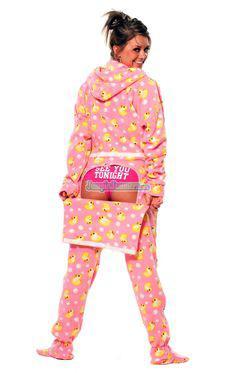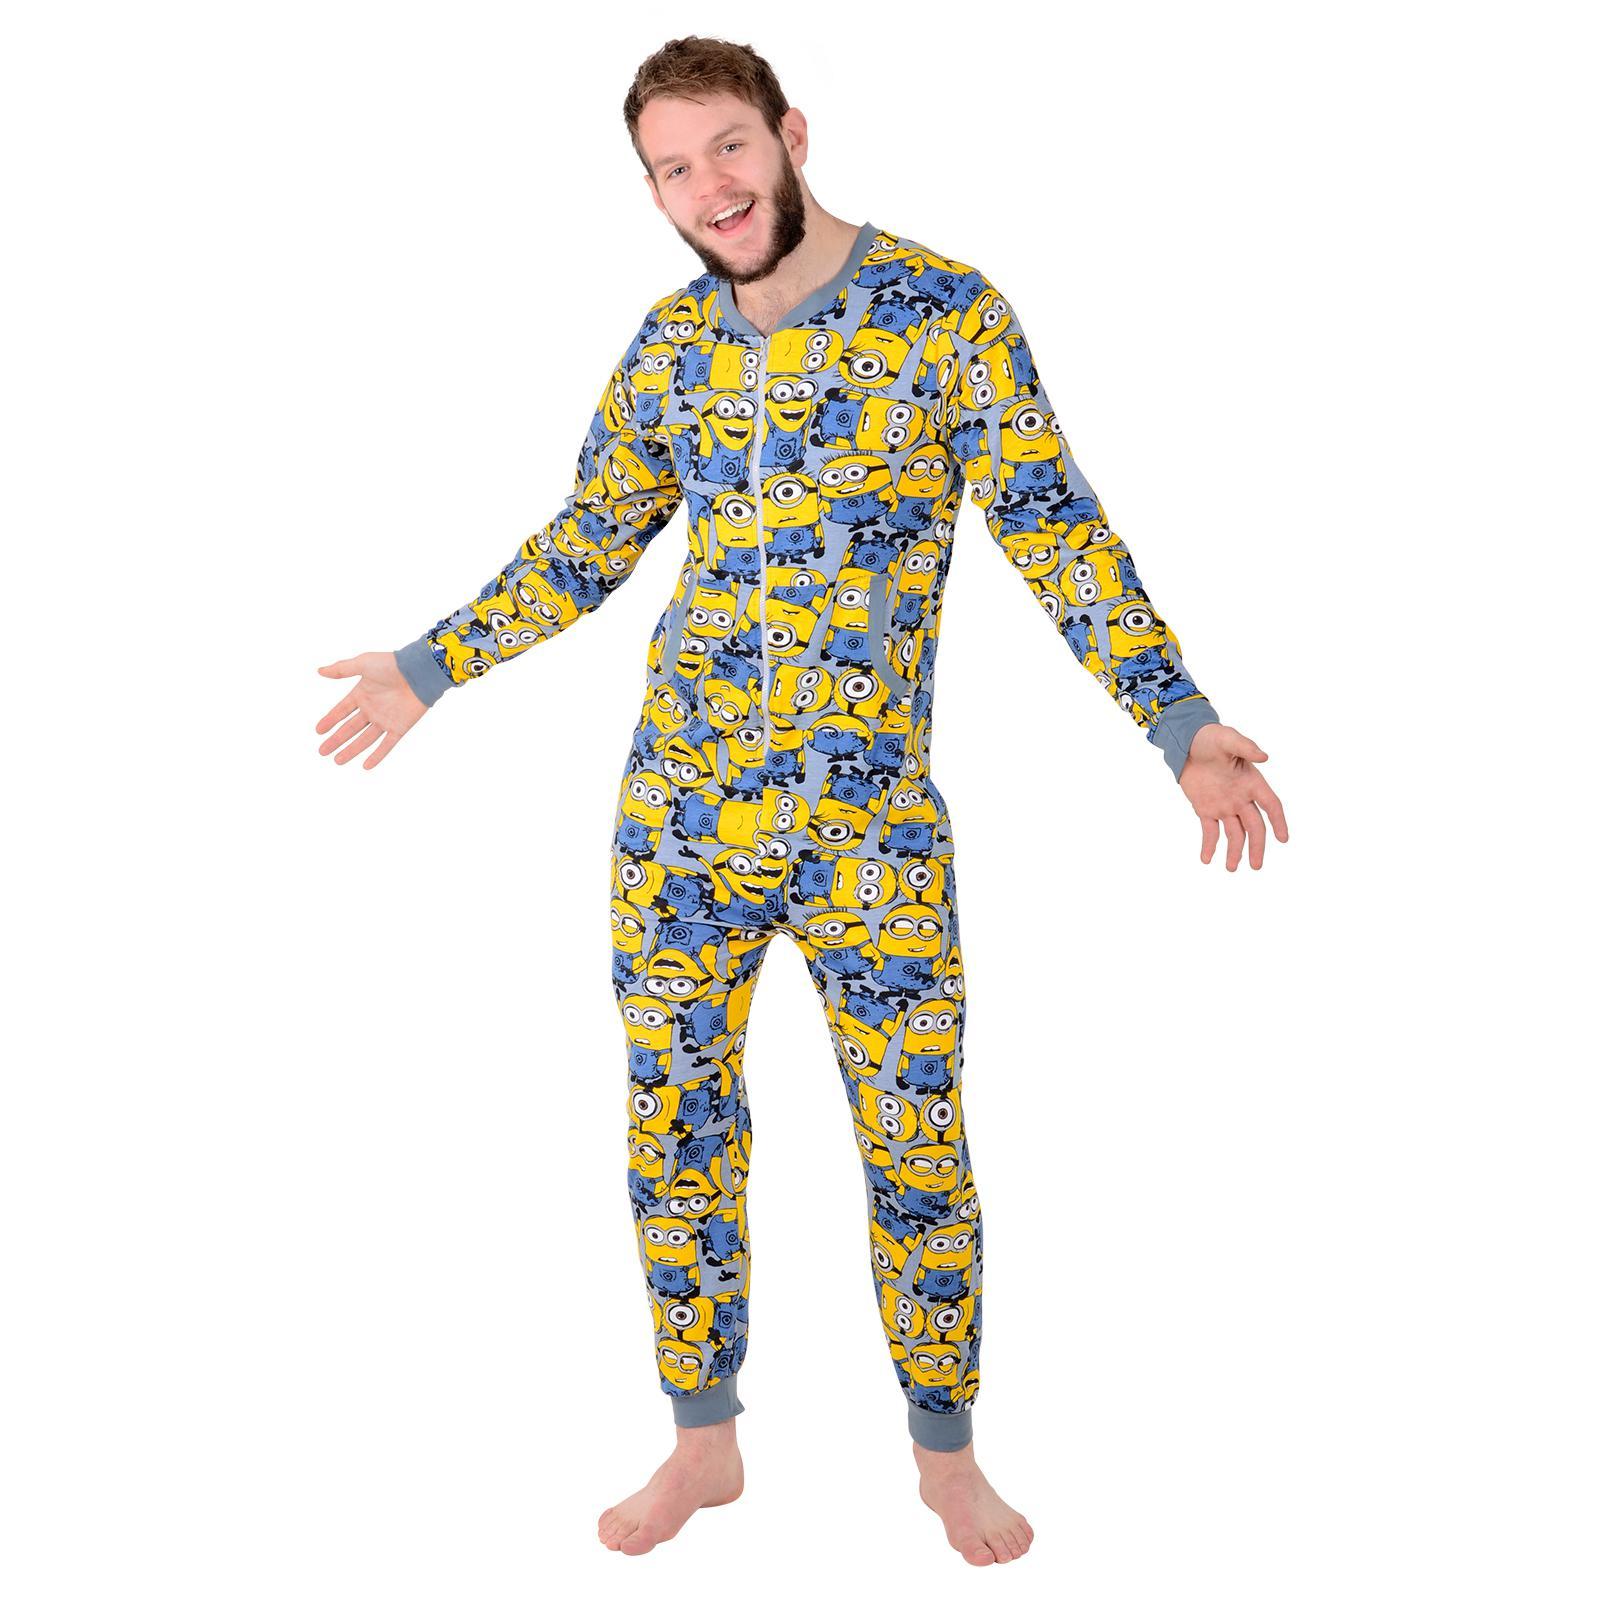The first image is the image on the left, the second image is the image on the right. For the images displayed, is the sentence "Two women are wearing footed pajamas, one of them with the attached hood pulled over her head." factually correct? Answer yes or no. No. The first image is the image on the left, the second image is the image on the right. For the images shown, is this caption "Both images must be females." true? Answer yes or no. No. 